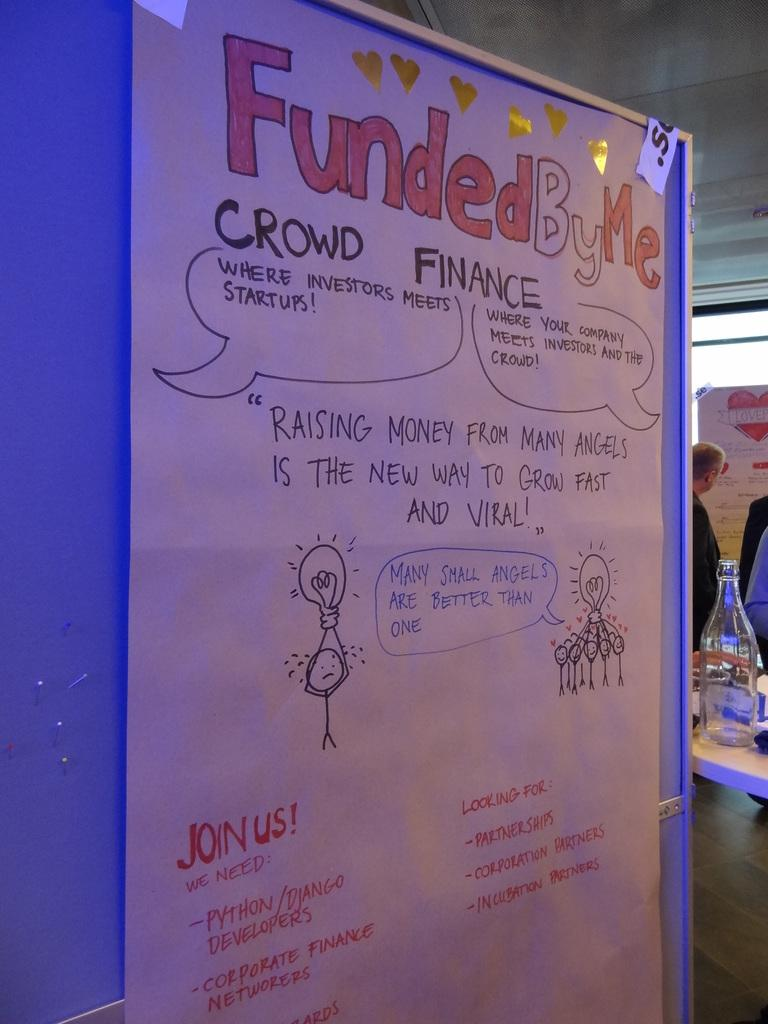What is the color of the board in the image? The board in the image is blue. What is placed on the blue board? There is a magazine on the board. What can be seen in the background of the image? There are people standing near a table in the image. What is on the table in the image? There are items placed on the table. What type of oranges can be seen growing on the tree in the image? There is no tree or oranges present in the image; it features a blue color board with a magazine and people standing near a table. 